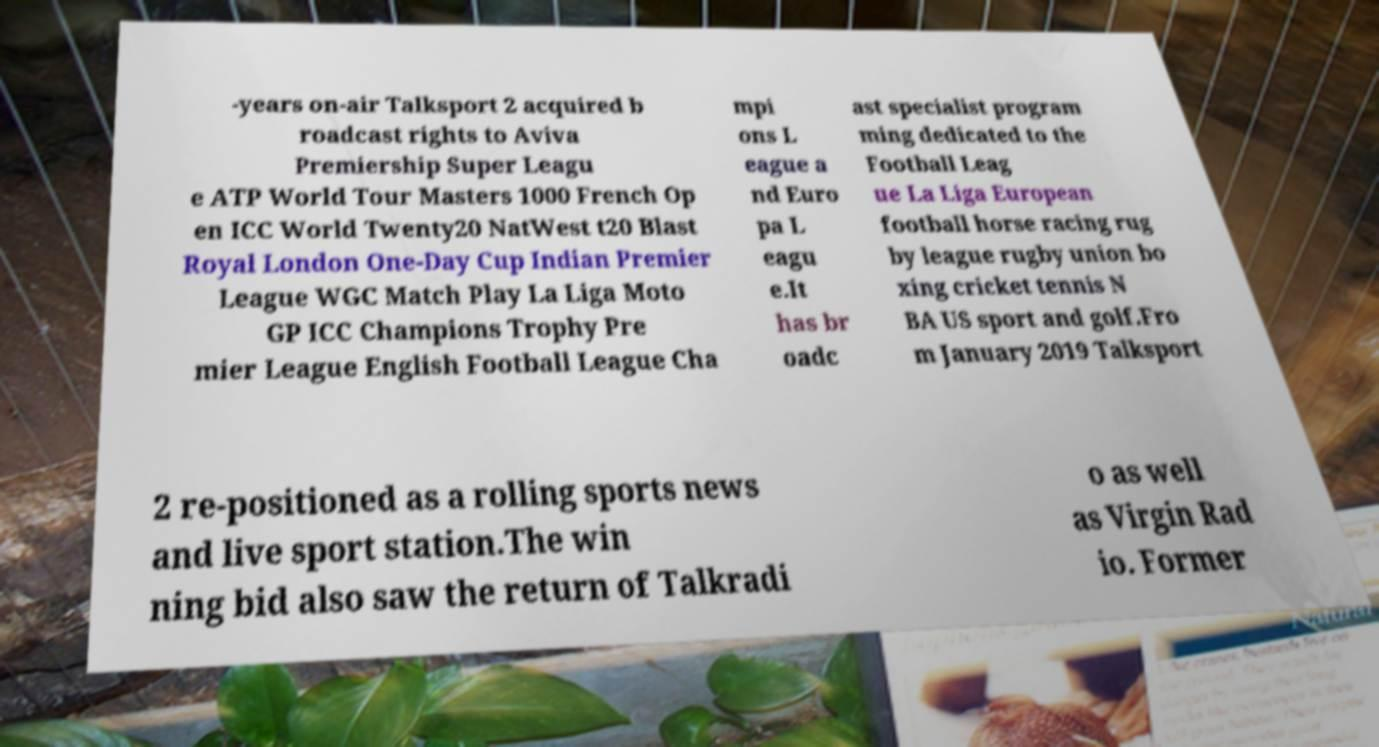I need the written content from this picture converted into text. Can you do that? -years on-air Talksport 2 acquired b roadcast rights to Aviva Premiership Super Leagu e ATP World Tour Masters 1000 French Op en ICC World Twenty20 NatWest t20 Blast Royal London One-Day Cup Indian Premier League WGC Match Play La Liga Moto GP ICC Champions Trophy Pre mier League English Football League Cha mpi ons L eague a nd Euro pa L eagu e.It has br oadc ast specialist program ming dedicated to the Football Leag ue La Liga European football horse racing rug by league rugby union bo xing cricket tennis N BA US sport and golf.Fro m January 2019 Talksport 2 re-positioned as a rolling sports news and live sport station.The win ning bid also saw the return of Talkradi o as well as Virgin Rad io. Former 